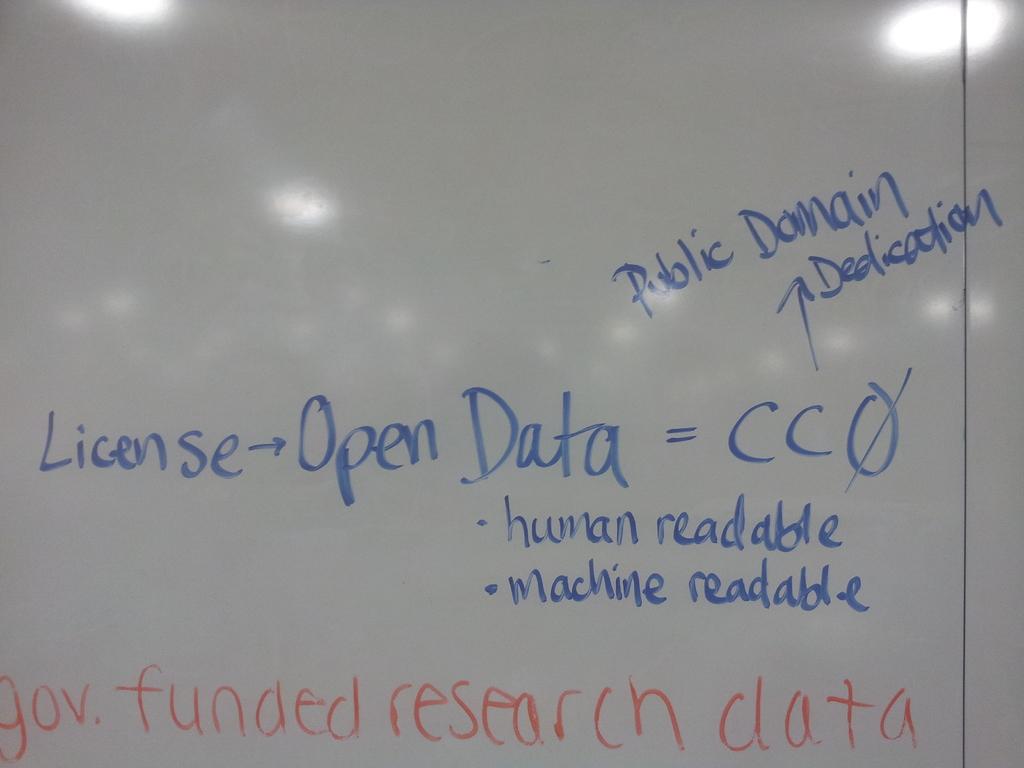Can this be read by a human and machine?
Make the answer very short. Yes. 